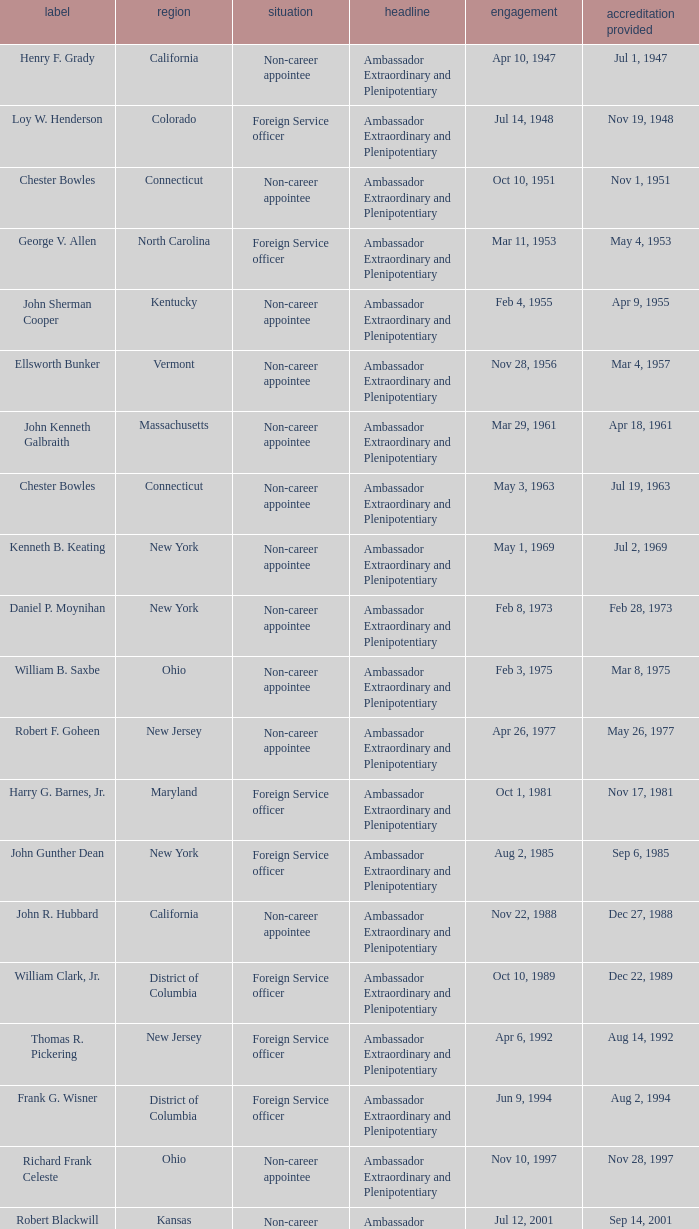What day was the appointment when Credentials Presented was jul 2, 1969? May 1, 1969. 